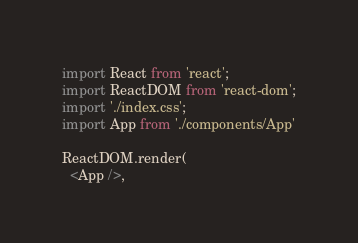Convert code to text. <code><loc_0><loc_0><loc_500><loc_500><_JavaScript_>import React from 'react';
import ReactDOM from 'react-dom';
import './index.css';
import App from './components/App'

ReactDOM.render(
  <App />,</code> 